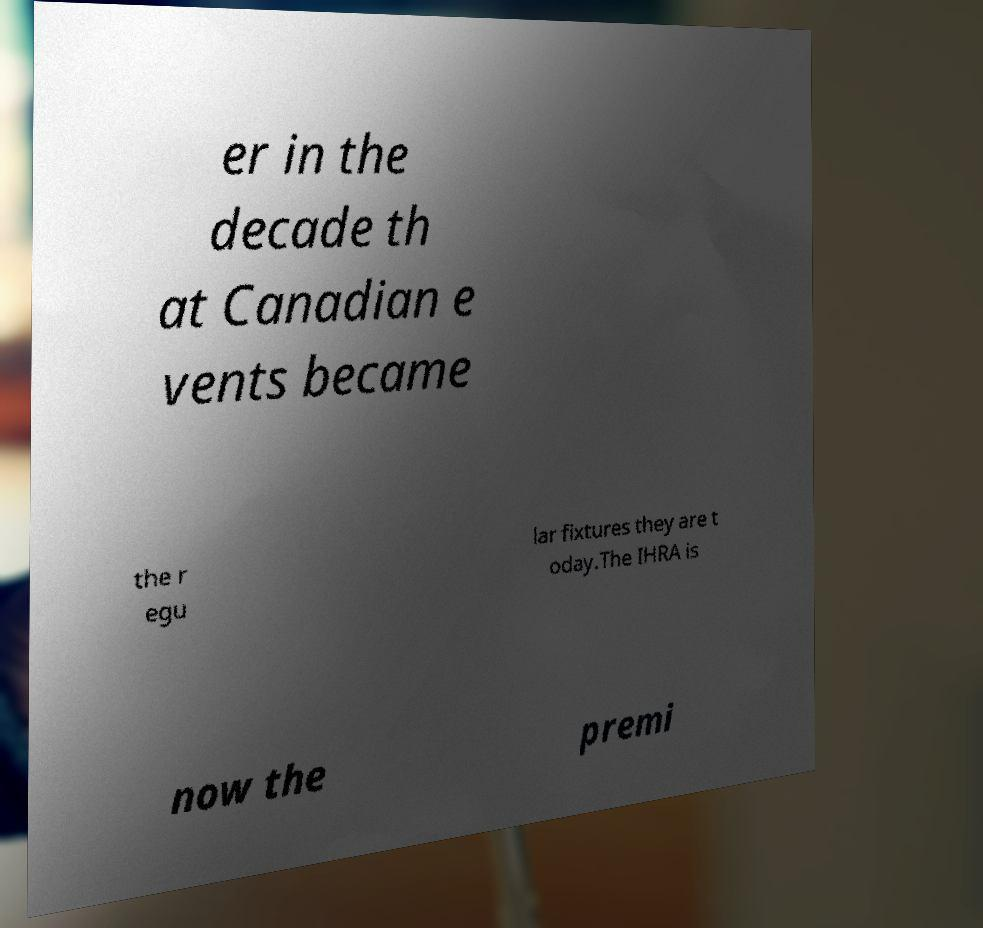Please identify and transcribe the text found in this image. er in the decade th at Canadian e vents became the r egu lar fixtures they are t oday.The IHRA is now the premi 